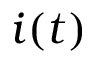Convert formula to latex. <formula><loc_0><loc_0><loc_500><loc_500>i ( t )</formula> 